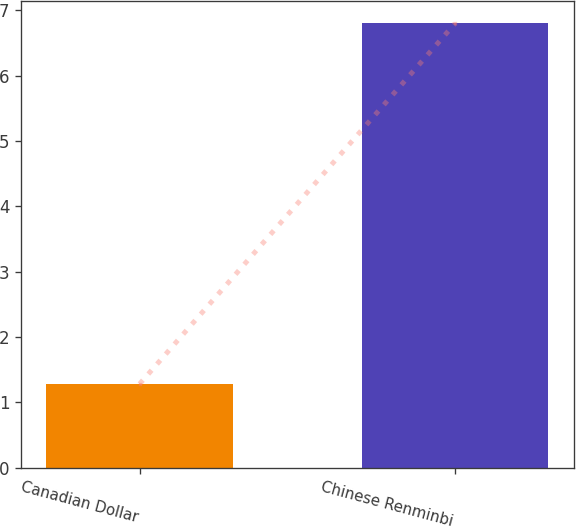<chart> <loc_0><loc_0><loc_500><loc_500><bar_chart><fcel>Canadian Dollar<fcel>Chinese Renminbi<nl><fcel>1.28<fcel>6.8<nl></chart> 